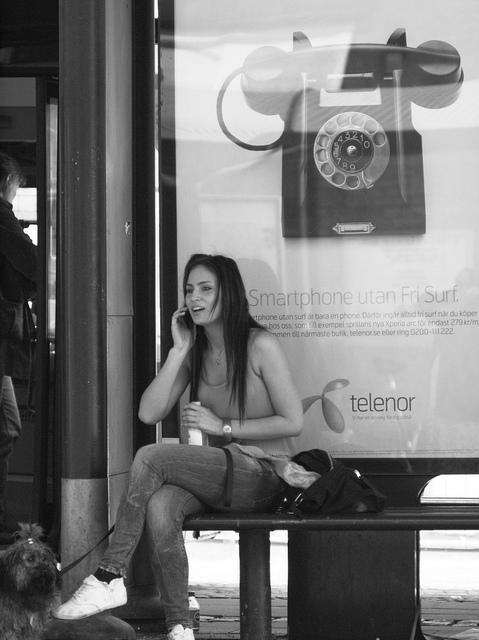How many handbags are in the photo?
Give a very brief answer. 1. How many people can be seen?
Give a very brief answer. 2. 